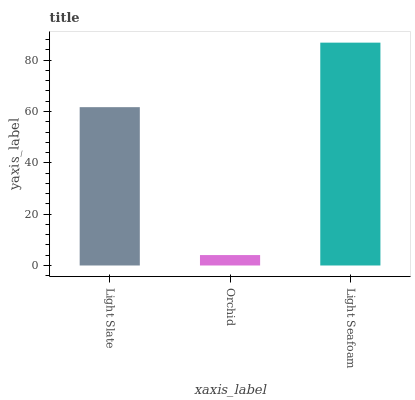Is Orchid the minimum?
Answer yes or no. Yes. Is Light Seafoam the maximum?
Answer yes or no. Yes. Is Light Seafoam the minimum?
Answer yes or no. No. Is Orchid the maximum?
Answer yes or no. No. Is Light Seafoam greater than Orchid?
Answer yes or no. Yes. Is Orchid less than Light Seafoam?
Answer yes or no. Yes. Is Orchid greater than Light Seafoam?
Answer yes or no. No. Is Light Seafoam less than Orchid?
Answer yes or no. No. Is Light Slate the high median?
Answer yes or no. Yes. Is Light Slate the low median?
Answer yes or no. Yes. Is Orchid the high median?
Answer yes or no. No. Is Orchid the low median?
Answer yes or no. No. 